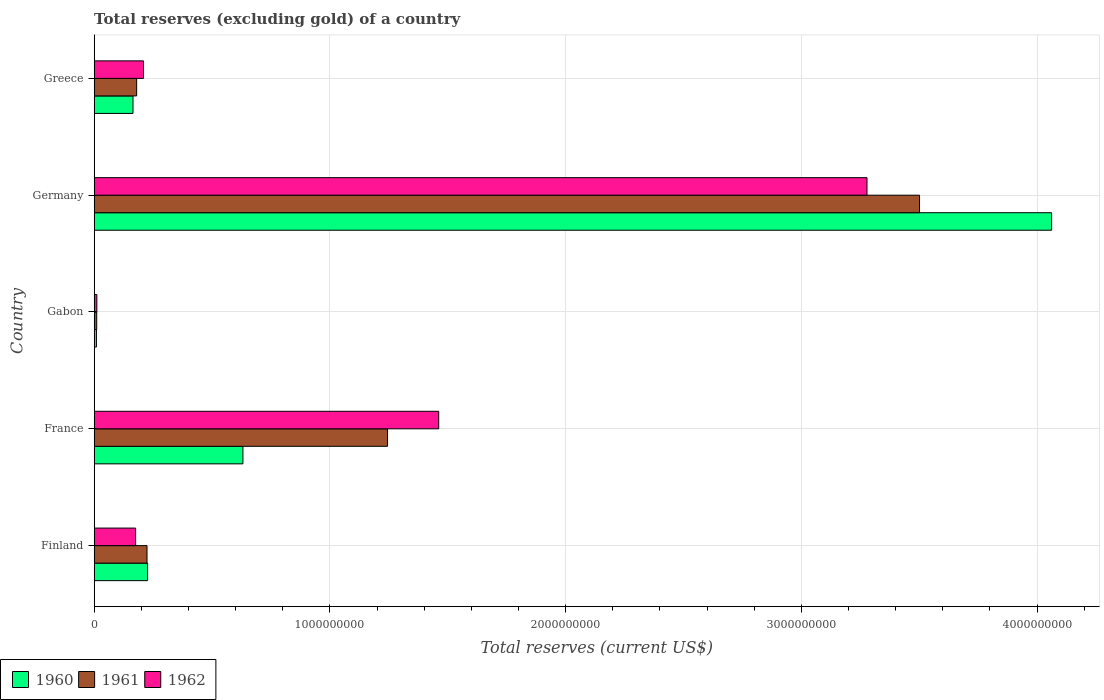How many different coloured bars are there?
Your response must be concise. 3. Are the number of bars per tick equal to the number of legend labels?
Give a very brief answer. Yes. Are the number of bars on each tick of the Y-axis equal?
Give a very brief answer. Yes. How many bars are there on the 2nd tick from the top?
Give a very brief answer. 3. How many bars are there on the 1st tick from the bottom?
Provide a succinct answer. 3. What is the total reserves (excluding gold) in 1962 in Germany?
Your answer should be compact. 3.28e+09. Across all countries, what is the maximum total reserves (excluding gold) in 1961?
Provide a succinct answer. 3.50e+09. Across all countries, what is the minimum total reserves (excluding gold) in 1961?
Offer a very short reply. 1.07e+07. In which country was the total reserves (excluding gold) in 1961 minimum?
Keep it short and to the point. Gabon. What is the total total reserves (excluding gold) in 1962 in the graph?
Make the answer very short. 5.14e+09. What is the difference between the total reserves (excluding gold) in 1962 in Gabon and that in Germany?
Your response must be concise. -3.27e+09. What is the difference between the total reserves (excluding gold) in 1962 in Germany and the total reserves (excluding gold) in 1961 in Finland?
Provide a succinct answer. 3.05e+09. What is the average total reserves (excluding gold) in 1961 per country?
Provide a short and direct response. 1.03e+09. What is the difference between the total reserves (excluding gold) in 1960 and total reserves (excluding gold) in 1961 in Finland?
Provide a succinct answer. 2.50e+06. In how many countries, is the total reserves (excluding gold) in 1961 greater than 1600000000 US$?
Offer a terse response. 1. What is the ratio of the total reserves (excluding gold) in 1962 in France to that in Germany?
Give a very brief answer. 0.45. Is the difference between the total reserves (excluding gold) in 1960 in Finland and Greece greater than the difference between the total reserves (excluding gold) in 1961 in Finland and Greece?
Ensure brevity in your answer.  Yes. What is the difference between the highest and the second highest total reserves (excluding gold) in 1961?
Keep it short and to the point. 2.26e+09. What is the difference between the highest and the lowest total reserves (excluding gold) in 1961?
Offer a very short reply. 3.49e+09. Is the sum of the total reserves (excluding gold) in 1961 in Gabon and Germany greater than the maximum total reserves (excluding gold) in 1962 across all countries?
Ensure brevity in your answer.  Yes. What does the 3rd bar from the top in Germany represents?
Provide a short and direct response. 1960. Is it the case that in every country, the sum of the total reserves (excluding gold) in 1960 and total reserves (excluding gold) in 1961 is greater than the total reserves (excluding gold) in 1962?
Ensure brevity in your answer.  Yes. How many bars are there?
Your response must be concise. 15. Does the graph contain any zero values?
Keep it short and to the point. No. Where does the legend appear in the graph?
Offer a terse response. Bottom left. How many legend labels are there?
Your answer should be compact. 3. How are the legend labels stacked?
Provide a short and direct response. Horizontal. What is the title of the graph?
Your answer should be compact. Total reserves (excluding gold) of a country. Does "1991" appear as one of the legend labels in the graph?
Give a very brief answer. No. What is the label or title of the X-axis?
Offer a terse response. Total reserves (current US$). What is the Total reserves (current US$) in 1960 in Finland?
Offer a terse response. 2.27e+08. What is the Total reserves (current US$) of 1961 in Finland?
Provide a succinct answer. 2.24e+08. What is the Total reserves (current US$) of 1962 in Finland?
Offer a very short reply. 1.76e+08. What is the Total reserves (current US$) in 1960 in France?
Keep it short and to the point. 6.31e+08. What is the Total reserves (current US$) in 1961 in France?
Your response must be concise. 1.24e+09. What is the Total reserves (current US$) of 1962 in France?
Provide a short and direct response. 1.46e+09. What is the Total reserves (current US$) in 1960 in Gabon?
Keep it short and to the point. 9.50e+06. What is the Total reserves (current US$) in 1961 in Gabon?
Keep it short and to the point. 1.07e+07. What is the Total reserves (current US$) in 1962 in Gabon?
Offer a terse response. 1.12e+07. What is the Total reserves (current US$) in 1960 in Germany?
Offer a very short reply. 4.06e+09. What is the Total reserves (current US$) in 1961 in Germany?
Keep it short and to the point. 3.50e+09. What is the Total reserves (current US$) of 1962 in Germany?
Provide a succinct answer. 3.28e+09. What is the Total reserves (current US$) in 1960 in Greece?
Provide a succinct answer. 1.65e+08. What is the Total reserves (current US$) in 1961 in Greece?
Offer a terse response. 1.80e+08. What is the Total reserves (current US$) of 1962 in Greece?
Ensure brevity in your answer.  2.09e+08. Across all countries, what is the maximum Total reserves (current US$) in 1960?
Provide a succinct answer. 4.06e+09. Across all countries, what is the maximum Total reserves (current US$) of 1961?
Offer a very short reply. 3.50e+09. Across all countries, what is the maximum Total reserves (current US$) of 1962?
Offer a terse response. 3.28e+09. Across all countries, what is the minimum Total reserves (current US$) in 1960?
Offer a very short reply. 9.50e+06. Across all countries, what is the minimum Total reserves (current US$) of 1961?
Give a very brief answer. 1.07e+07. Across all countries, what is the minimum Total reserves (current US$) in 1962?
Your answer should be very brief. 1.12e+07. What is the total Total reserves (current US$) of 1960 in the graph?
Offer a terse response. 5.09e+09. What is the total Total reserves (current US$) in 1961 in the graph?
Keep it short and to the point. 5.16e+09. What is the total Total reserves (current US$) of 1962 in the graph?
Your answer should be very brief. 5.14e+09. What is the difference between the Total reserves (current US$) in 1960 in Finland and that in France?
Offer a terse response. -4.04e+08. What is the difference between the Total reserves (current US$) in 1961 in Finland and that in France?
Provide a short and direct response. -1.02e+09. What is the difference between the Total reserves (current US$) of 1962 in Finland and that in France?
Provide a succinct answer. -1.29e+09. What is the difference between the Total reserves (current US$) of 1960 in Finland and that in Gabon?
Your answer should be very brief. 2.17e+08. What is the difference between the Total reserves (current US$) in 1961 in Finland and that in Gabon?
Offer a very short reply. 2.13e+08. What is the difference between the Total reserves (current US$) in 1962 in Finland and that in Gabon?
Give a very brief answer. 1.64e+08. What is the difference between the Total reserves (current US$) of 1960 in Finland and that in Germany?
Provide a succinct answer. -3.84e+09. What is the difference between the Total reserves (current US$) in 1961 in Finland and that in Germany?
Give a very brief answer. -3.28e+09. What is the difference between the Total reserves (current US$) in 1962 in Finland and that in Germany?
Give a very brief answer. -3.10e+09. What is the difference between the Total reserves (current US$) in 1960 in Finland and that in Greece?
Your answer should be very brief. 6.20e+07. What is the difference between the Total reserves (current US$) of 1961 in Finland and that in Greece?
Keep it short and to the point. 4.40e+07. What is the difference between the Total reserves (current US$) in 1962 in Finland and that in Greece?
Provide a short and direct response. -3.35e+07. What is the difference between the Total reserves (current US$) of 1960 in France and that in Gabon?
Make the answer very short. 6.21e+08. What is the difference between the Total reserves (current US$) of 1961 in France and that in Gabon?
Offer a very short reply. 1.23e+09. What is the difference between the Total reserves (current US$) of 1962 in France and that in Gabon?
Your answer should be compact. 1.45e+09. What is the difference between the Total reserves (current US$) of 1960 in France and that in Germany?
Offer a terse response. -3.43e+09. What is the difference between the Total reserves (current US$) of 1961 in France and that in Germany?
Ensure brevity in your answer.  -2.26e+09. What is the difference between the Total reserves (current US$) in 1962 in France and that in Germany?
Offer a very short reply. -1.82e+09. What is the difference between the Total reserves (current US$) of 1960 in France and that in Greece?
Keep it short and to the point. 4.66e+08. What is the difference between the Total reserves (current US$) of 1961 in France and that in Greece?
Your answer should be very brief. 1.06e+09. What is the difference between the Total reserves (current US$) in 1962 in France and that in Greece?
Your response must be concise. 1.25e+09. What is the difference between the Total reserves (current US$) in 1960 in Gabon and that in Germany?
Provide a succinct answer. -4.05e+09. What is the difference between the Total reserves (current US$) in 1961 in Gabon and that in Germany?
Ensure brevity in your answer.  -3.49e+09. What is the difference between the Total reserves (current US$) in 1962 in Gabon and that in Germany?
Your response must be concise. -3.27e+09. What is the difference between the Total reserves (current US$) in 1960 in Gabon and that in Greece?
Your response must be concise. -1.55e+08. What is the difference between the Total reserves (current US$) of 1961 in Gabon and that in Greece?
Offer a very short reply. -1.69e+08. What is the difference between the Total reserves (current US$) in 1962 in Gabon and that in Greece?
Offer a terse response. -1.98e+08. What is the difference between the Total reserves (current US$) in 1960 in Germany and that in Greece?
Provide a short and direct response. 3.90e+09. What is the difference between the Total reserves (current US$) of 1961 in Germany and that in Greece?
Keep it short and to the point. 3.32e+09. What is the difference between the Total reserves (current US$) of 1962 in Germany and that in Greece?
Give a very brief answer. 3.07e+09. What is the difference between the Total reserves (current US$) in 1960 in Finland and the Total reserves (current US$) in 1961 in France?
Keep it short and to the point. -1.02e+09. What is the difference between the Total reserves (current US$) in 1960 in Finland and the Total reserves (current US$) in 1962 in France?
Make the answer very short. -1.23e+09. What is the difference between the Total reserves (current US$) in 1961 in Finland and the Total reserves (current US$) in 1962 in France?
Keep it short and to the point. -1.24e+09. What is the difference between the Total reserves (current US$) in 1960 in Finland and the Total reserves (current US$) in 1961 in Gabon?
Give a very brief answer. 2.16e+08. What is the difference between the Total reserves (current US$) of 1960 in Finland and the Total reserves (current US$) of 1962 in Gabon?
Provide a succinct answer. 2.15e+08. What is the difference between the Total reserves (current US$) of 1961 in Finland and the Total reserves (current US$) of 1962 in Gabon?
Keep it short and to the point. 2.13e+08. What is the difference between the Total reserves (current US$) in 1960 in Finland and the Total reserves (current US$) in 1961 in Germany?
Provide a short and direct response. -3.27e+09. What is the difference between the Total reserves (current US$) in 1960 in Finland and the Total reserves (current US$) in 1962 in Germany?
Make the answer very short. -3.05e+09. What is the difference between the Total reserves (current US$) in 1961 in Finland and the Total reserves (current US$) in 1962 in Germany?
Your answer should be very brief. -3.05e+09. What is the difference between the Total reserves (current US$) in 1960 in Finland and the Total reserves (current US$) in 1961 in Greece?
Ensure brevity in your answer.  4.65e+07. What is the difference between the Total reserves (current US$) in 1960 in Finland and the Total reserves (current US$) in 1962 in Greece?
Offer a terse response. 1.74e+07. What is the difference between the Total reserves (current US$) of 1961 in Finland and the Total reserves (current US$) of 1962 in Greece?
Your response must be concise. 1.49e+07. What is the difference between the Total reserves (current US$) of 1960 in France and the Total reserves (current US$) of 1961 in Gabon?
Your answer should be very brief. 6.20e+08. What is the difference between the Total reserves (current US$) in 1960 in France and the Total reserves (current US$) in 1962 in Gabon?
Provide a succinct answer. 6.20e+08. What is the difference between the Total reserves (current US$) of 1961 in France and the Total reserves (current US$) of 1962 in Gabon?
Your answer should be compact. 1.23e+09. What is the difference between the Total reserves (current US$) of 1960 in France and the Total reserves (current US$) of 1961 in Germany?
Make the answer very short. -2.87e+09. What is the difference between the Total reserves (current US$) in 1960 in France and the Total reserves (current US$) in 1962 in Germany?
Give a very brief answer. -2.65e+09. What is the difference between the Total reserves (current US$) of 1961 in France and the Total reserves (current US$) of 1962 in Germany?
Provide a succinct answer. -2.03e+09. What is the difference between the Total reserves (current US$) of 1960 in France and the Total reserves (current US$) of 1961 in Greece?
Offer a very short reply. 4.51e+08. What is the difference between the Total reserves (current US$) of 1960 in France and the Total reserves (current US$) of 1962 in Greece?
Your answer should be very brief. 4.22e+08. What is the difference between the Total reserves (current US$) of 1961 in France and the Total reserves (current US$) of 1962 in Greece?
Provide a short and direct response. 1.04e+09. What is the difference between the Total reserves (current US$) of 1960 in Gabon and the Total reserves (current US$) of 1961 in Germany?
Your answer should be very brief. -3.49e+09. What is the difference between the Total reserves (current US$) in 1960 in Gabon and the Total reserves (current US$) in 1962 in Germany?
Your response must be concise. -3.27e+09. What is the difference between the Total reserves (current US$) of 1961 in Gabon and the Total reserves (current US$) of 1962 in Germany?
Offer a terse response. -3.27e+09. What is the difference between the Total reserves (current US$) in 1960 in Gabon and the Total reserves (current US$) in 1961 in Greece?
Your answer should be very brief. -1.71e+08. What is the difference between the Total reserves (current US$) in 1960 in Gabon and the Total reserves (current US$) in 1962 in Greece?
Offer a very short reply. -2.00e+08. What is the difference between the Total reserves (current US$) of 1961 in Gabon and the Total reserves (current US$) of 1962 in Greece?
Provide a succinct answer. -1.98e+08. What is the difference between the Total reserves (current US$) in 1960 in Germany and the Total reserves (current US$) in 1961 in Greece?
Provide a short and direct response. 3.88e+09. What is the difference between the Total reserves (current US$) in 1960 in Germany and the Total reserves (current US$) in 1962 in Greece?
Ensure brevity in your answer.  3.85e+09. What is the difference between the Total reserves (current US$) of 1961 in Germany and the Total reserves (current US$) of 1962 in Greece?
Offer a terse response. 3.29e+09. What is the average Total reserves (current US$) in 1960 per country?
Keep it short and to the point. 1.02e+09. What is the average Total reserves (current US$) in 1961 per country?
Ensure brevity in your answer.  1.03e+09. What is the average Total reserves (current US$) of 1962 per country?
Your answer should be compact. 1.03e+09. What is the difference between the Total reserves (current US$) of 1960 and Total reserves (current US$) of 1961 in Finland?
Ensure brevity in your answer.  2.50e+06. What is the difference between the Total reserves (current US$) of 1960 and Total reserves (current US$) of 1962 in Finland?
Provide a succinct answer. 5.09e+07. What is the difference between the Total reserves (current US$) of 1961 and Total reserves (current US$) of 1962 in Finland?
Offer a very short reply. 4.84e+07. What is the difference between the Total reserves (current US$) in 1960 and Total reserves (current US$) in 1961 in France?
Offer a very short reply. -6.14e+08. What is the difference between the Total reserves (current US$) in 1960 and Total reserves (current US$) in 1962 in France?
Make the answer very short. -8.31e+08. What is the difference between the Total reserves (current US$) of 1961 and Total reserves (current US$) of 1962 in France?
Your answer should be compact. -2.17e+08. What is the difference between the Total reserves (current US$) of 1960 and Total reserves (current US$) of 1961 in Gabon?
Ensure brevity in your answer.  -1.20e+06. What is the difference between the Total reserves (current US$) in 1960 and Total reserves (current US$) in 1962 in Gabon?
Provide a succinct answer. -1.75e+06. What is the difference between the Total reserves (current US$) of 1961 and Total reserves (current US$) of 1962 in Gabon?
Offer a terse response. -5.50e+05. What is the difference between the Total reserves (current US$) in 1960 and Total reserves (current US$) in 1961 in Germany?
Give a very brief answer. 5.60e+08. What is the difference between the Total reserves (current US$) of 1960 and Total reserves (current US$) of 1962 in Germany?
Keep it short and to the point. 7.83e+08. What is the difference between the Total reserves (current US$) in 1961 and Total reserves (current US$) in 1962 in Germany?
Offer a terse response. 2.23e+08. What is the difference between the Total reserves (current US$) in 1960 and Total reserves (current US$) in 1961 in Greece?
Offer a terse response. -1.55e+07. What is the difference between the Total reserves (current US$) in 1960 and Total reserves (current US$) in 1962 in Greece?
Offer a terse response. -4.46e+07. What is the difference between the Total reserves (current US$) of 1961 and Total reserves (current US$) of 1962 in Greece?
Provide a succinct answer. -2.91e+07. What is the ratio of the Total reserves (current US$) in 1960 in Finland to that in France?
Provide a short and direct response. 0.36. What is the ratio of the Total reserves (current US$) in 1961 in Finland to that in France?
Ensure brevity in your answer.  0.18. What is the ratio of the Total reserves (current US$) in 1962 in Finland to that in France?
Give a very brief answer. 0.12. What is the ratio of the Total reserves (current US$) of 1960 in Finland to that in Gabon?
Give a very brief answer. 23.85. What is the ratio of the Total reserves (current US$) in 1961 in Finland to that in Gabon?
Offer a very short reply. 20.94. What is the ratio of the Total reserves (current US$) in 1962 in Finland to that in Gabon?
Give a very brief answer. 15.62. What is the ratio of the Total reserves (current US$) in 1960 in Finland to that in Germany?
Ensure brevity in your answer.  0.06. What is the ratio of the Total reserves (current US$) of 1961 in Finland to that in Germany?
Your answer should be compact. 0.06. What is the ratio of the Total reserves (current US$) in 1962 in Finland to that in Germany?
Your answer should be compact. 0.05. What is the ratio of the Total reserves (current US$) of 1960 in Finland to that in Greece?
Your answer should be compact. 1.38. What is the ratio of the Total reserves (current US$) in 1961 in Finland to that in Greece?
Give a very brief answer. 1.24. What is the ratio of the Total reserves (current US$) in 1962 in Finland to that in Greece?
Your response must be concise. 0.84. What is the ratio of the Total reserves (current US$) of 1960 in France to that in Gabon?
Offer a very short reply. 66.41. What is the ratio of the Total reserves (current US$) of 1961 in France to that in Gabon?
Your response must be concise. 116.3. What is the ratio of the Total reserves (current US$) of 1962 in France to that in Gabon?
Provide a succinct answer. 129.91. What is the ratio of the Total reserves (current US$) of 1960 in France to that in Germany?
Your answer should be compact. 0.16. What is the ratio of the Total reserves (current US$) of 1961 in France to that in Germany?
Offer a very short reply. 0.36. What is the ratio of the Total reserves (current US$) of 1962 in France to that in Germany?
Offer a very short reply. 0.45. What is the ratio of the Total reserves (current US$) in 1960 in France to that in Greece?
Your response must be concise. 3.83. What is the ratio of the Total reserves (current US$) in 1961 in France to that in Greece?
Your answer should be very brief. 6.91. What is the ratio of the Total reserves (current US$) of 1962 in France to that in Greece?
Provide a short and direct response. 6.99. What is the ratio of the Total reserves (current US$) in 1960 in Gabon to that in Germany?
Keep it short and to the point. 0. What is the ratio of the Total reserves (current US$) of 1961 in Gabon to that in Germany?
Keep it short and to the point. 0. What is the ratio of the Total reserves (current US$) in 1962 in Gabon to that in Germany?
Your answer should be very brief. 0. What is the ratio of the Total reserves (current US$) in 1960 in Gabon to that in Greece?
Your answer should be very brief. 0.06. What is the ratio of the Total reserves (current US$) in 1961 in Gabon to that in Greece?
Make the answer very short. 0.06. What is the ratio of the Total reserves (current US$) of 1962 in Gabon to that in Greece?
Keep it short and to the point. 0.05. What is the ratio of the Total reserves (current US$) in 1960 in Germany to that in Greece?
Your answer should be very brief. 24.68. What is the ratio of the Total reserves (current US$) in 1961 in Germany to that in Greece?
Your answer should be compact. 19.44. What is the ratio of the Total reserves (current US$) in 1962 in Germany to that in Greece?
Ensure brevity in your answer.  15.67. What is the difference between the highest and the second highest Total reserves (current US$) in 1960?
Offer a very short reply. 3.43e+09. What is the difference between the highest and the second highest Total reserves (current US$) in 1961?
Provide a succinct answer. 2.26e+09. What is the difference between the highest and the second highest Total reserves (current US$) in 1962?
Ensure brevity in your answer.  1.82e+09. What is the difference between the highest and the lowest Total reserves (current US$) of 1960?
Ensure brevity in your answer.  4.05e+09. What is the difference between the highest and the lowest Total reserves (current US$) of 1961?
Give a very brief answer. 3.49e+09. What is the difference between the highest and the lowest Total reserves (current US$) of 1962?
Provide a succinct answer. 3.27e+09. 